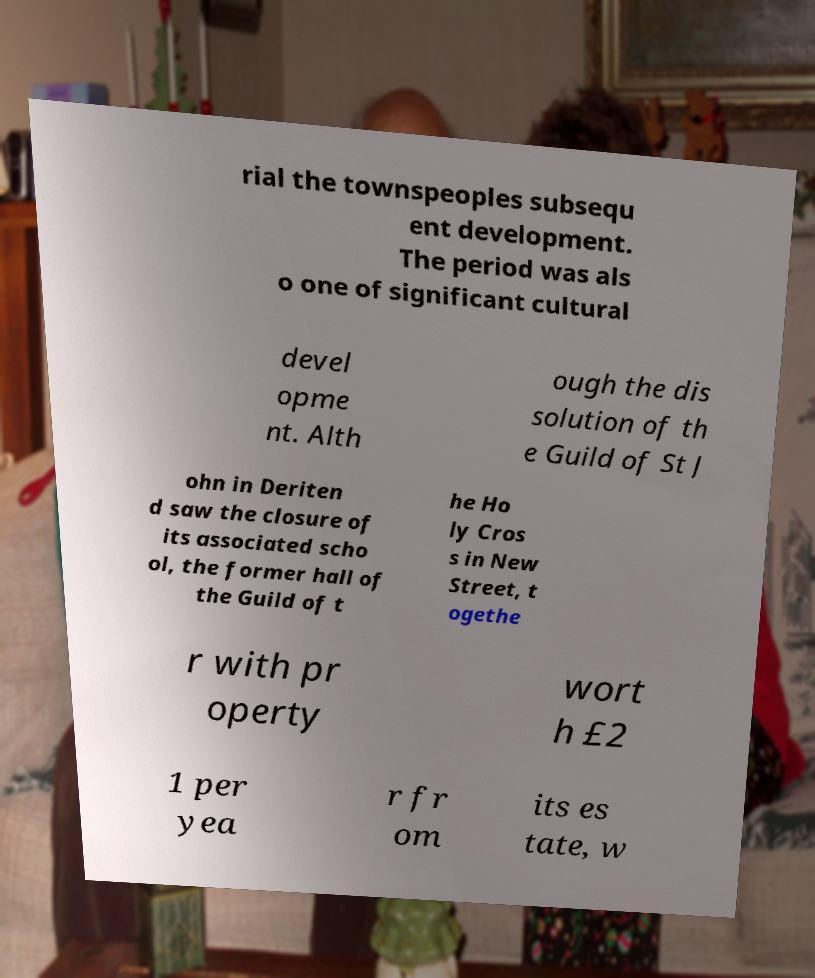Please read and relay the text visible in this image. What does it say? rial the townspeoples subsequ ent development. The period was als o one of significant cultural devel opme nt. Alth ough the dis solution of th e Guild of St J ohn in Deriten d saw the closure of its associated scho ol, the former hall of the Guild of t he Ho ly Cros s in New Street, t ogethe r with pr operty wort h £2 1 per yea r fr om its es tate, w 